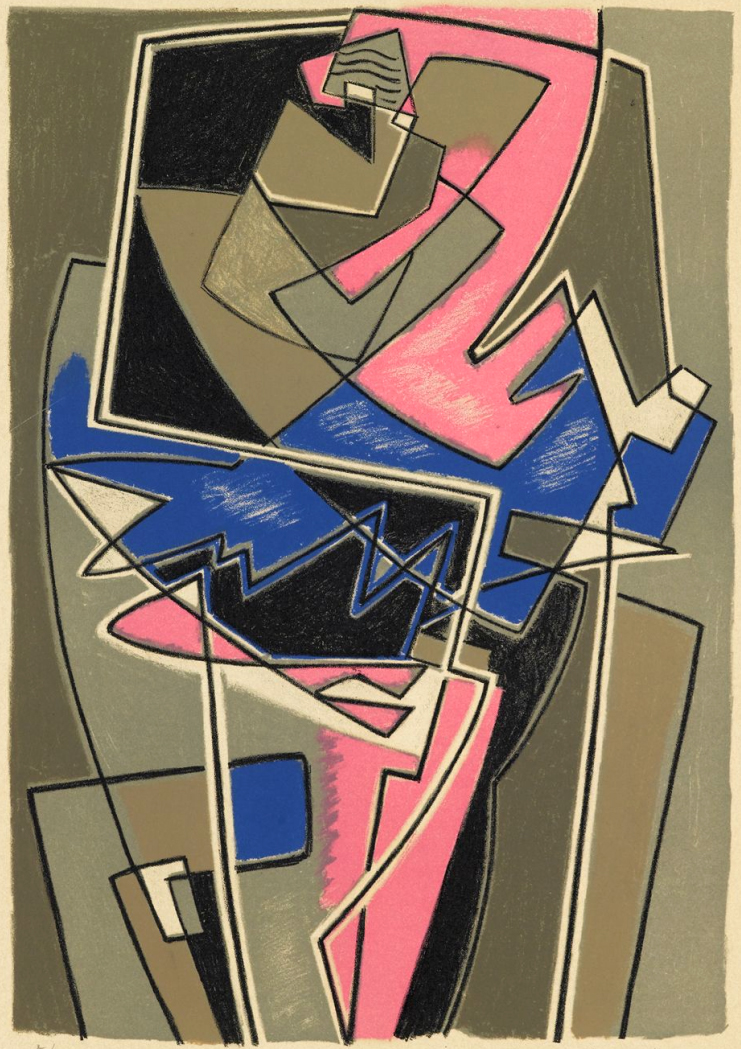What mood or atmosphere does this cubic art communicate, and how do the shapes contribute to it? The mood conveyed by this piece is one of dynamic tension and modernity, typical of the cubist movement's desire to revolutionize art. The overlapping shapes create a sense of complexity and fragmented reality which may evoke feelings of confusion or excitement. The sharp angles and contrasting colors further intensify these feelings, offering a vivid interpretation of reality that challenges the viewer’s perception and invites deeper reflection on the nature of visual representation. 